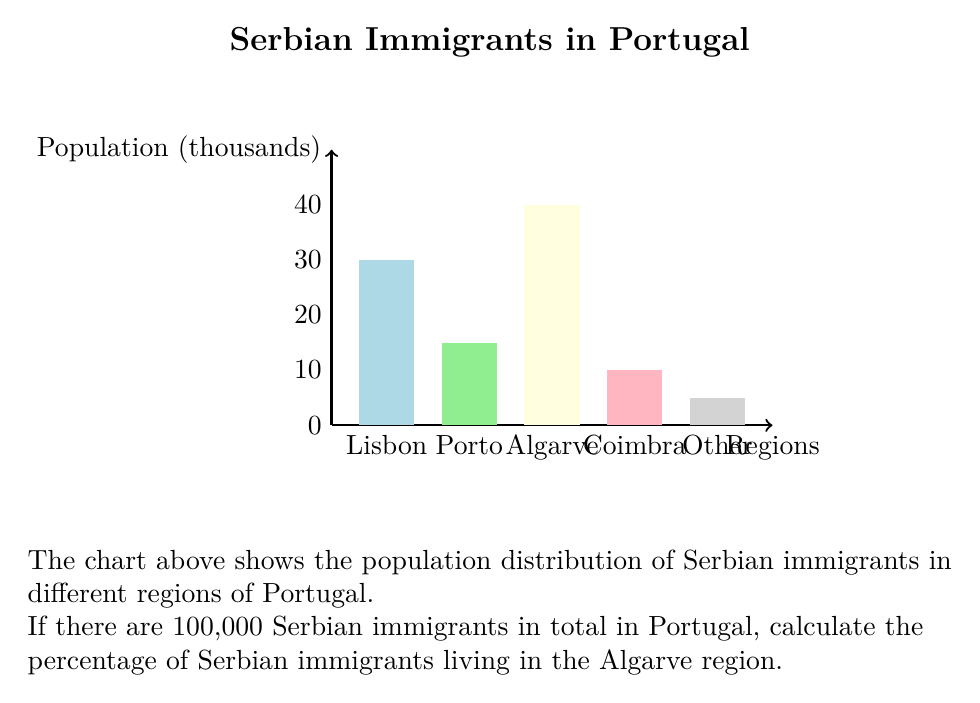What is the answer to this math problem? To solve this problem, we'll follow these steps:

1. Identify the number of Serbian immigrants in the Algarve region from the chart.
2. Calculate the percentage using the total number of Serbian immigrants.

Step 1: From the chart, we can see that the bar for the Algarve region reaches 40 on the y-axis. Since the y-axis is in thousands, this means there are 40,000 Serbian immigrants in the Algarve region.

Step 2: To calculate the percentage, we use the formula:

$$ \text{Percentage} = \frac{\text{Number in Algarve}}{\text{Total number}} \times 100\% $$

Plugging in the values:

$$ \text{Percentage} = \frac{40,000}{100,000} \times 100\% $$

$$ = 0.4 \times 100\% $$

$$ = 40\% $$

Therefore, 40% of Serbian immigrants in Portugal live in the Algarve region.
Answer: 40% 